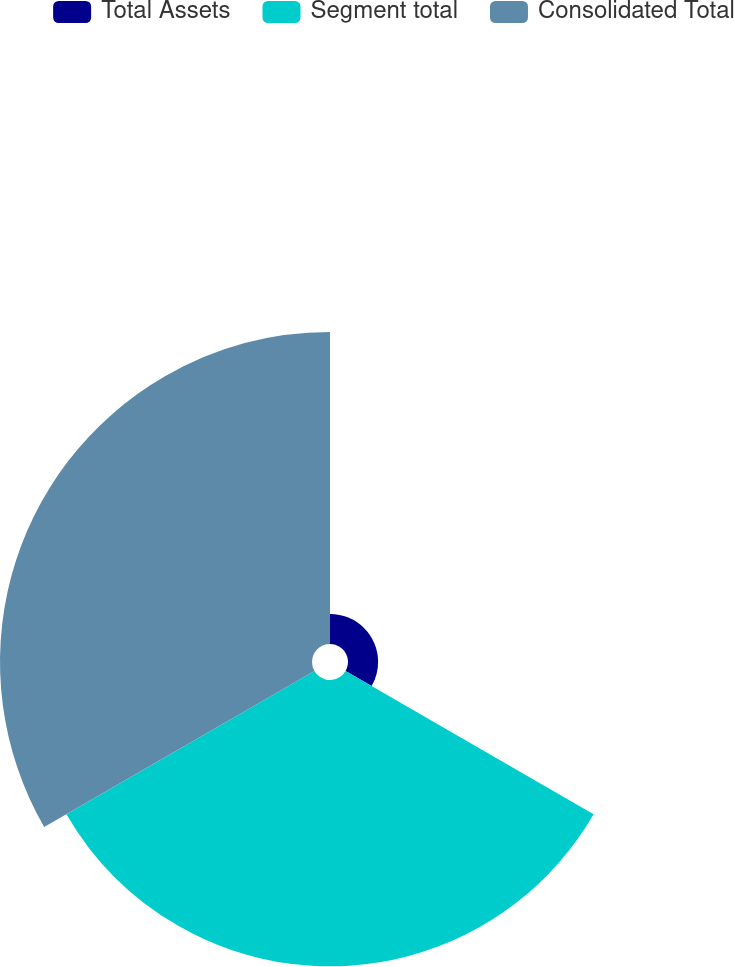Convert chart. <chart><loc_0><loc_0><loc_500><loc_500><pie_chart><fcel>Total Assets<fcel>Segment total<fcel>Consolidated Total<nl><fcel>4.79%<fcel>45.56%<fcel>49.64%<nl></chart> 